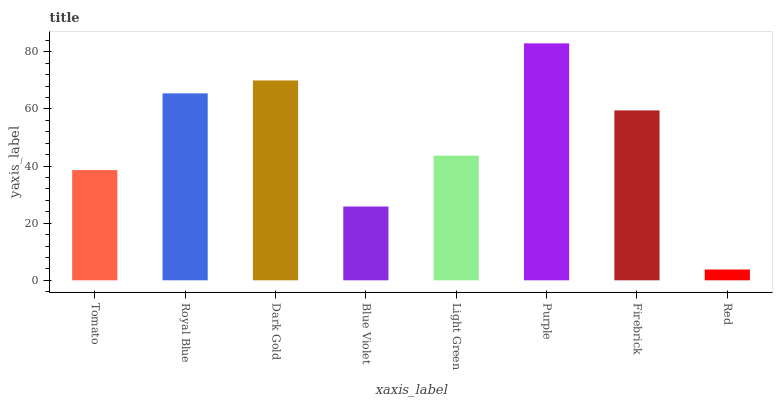Is Red the minimum?
Answer yes or no. Yes. Is Purple the maximum?
Answer yes or no. Yes. Is Royal Blue the minimum?
Answer yes or no. No. Is Royal Blue the maximum?
Answer yes or no. No. Is Royal Blue greater than Tomato?
Answer yes or no. Yes. Is Tomato less than Royal Blue?
Answer yes or no. Yes. Is Tomato greater than Royal Blue?
Answer yes or no. No. Is Royal Blue less than Tomato?
Answer yes or no. No. Is Firebrick the high median?
Answer yes or no. Yes. Is Light Green the low median?
Answer yes or no. Yes. Is Dark Gold the high median?
Answer yes or no. No. Is Dark Gold the low median?
Answer yes or no. No. 